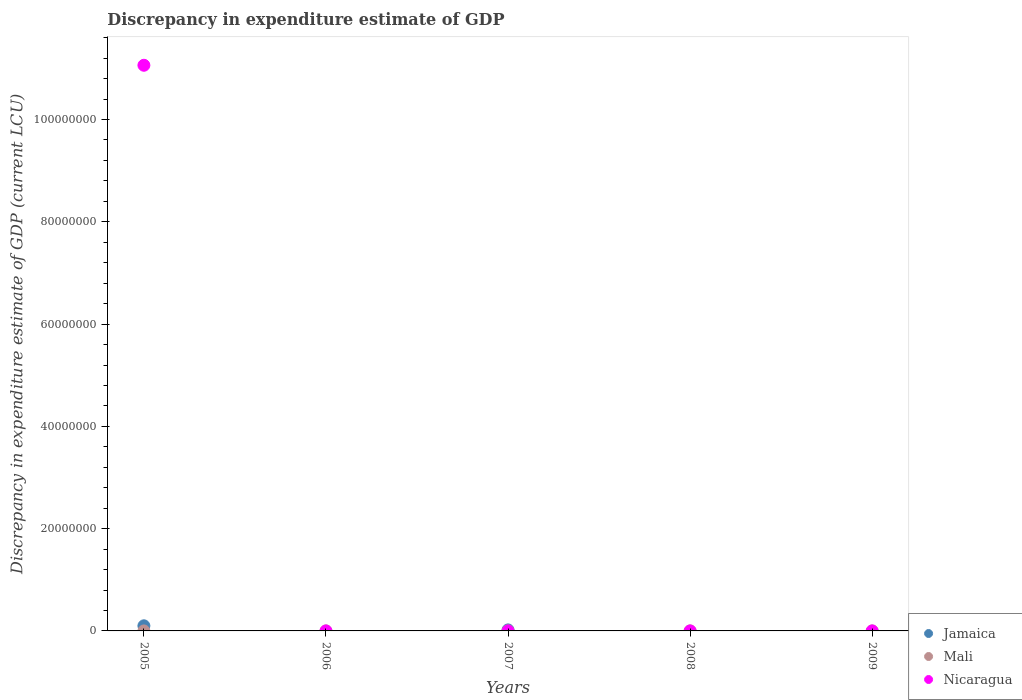How many different coloured dotlines are there?
Ensure brevity in your answer.  3. What is the discrepancy in expenditure estimate of GDP in Jamaica in 2005?
Provide a succinct answer. 1.00e+06. Across all years, what is the maximum discrepancy in expenditure estimate of GDP in Nicaragua?
Provide a succinct answer. 1.11e+08. What is the total discrepancy in expenditure estimate of GDP in Nicaragua in the graph?
Keep it short and to the point. 1.11e+08. What is the difference between the discrepancy in expenditure estimate of GDP in Mali in 2006 and that in 2008?
Provide a succinct answer. 0. What is the difference between the discrepancy in expenditure estimate of GDP in Nicaragua in 2006 and the discrepancy in expenditure estimate of GDP in Mali in 2007?
Provide a succinct answer. -0. What is the average discrepancy in expenditure estimate of GDP in Jamaica per year?
Keep it short and to the point. 2.40e+05. In the year 2007, what is the difference between the discrepancy in expenditure estimate of GDP in Jamaica and discrepancy in expenditure estimate of GDP in Mali?
Your response must be concise. 2.00e+05. In how many years, is the discrepancy in expenditure estimate of GDP in Jamaica greater than 108000000 LCU?
Provide a succinct answer. 0. What is the ratio of the discrepancy in expenditure estimate of GDP in Mali in 2005 to that in 2008?
Make the answer very short. 1.87. What is the difference between the highest and the lowest discrepancy in expenditure estimate of GDP in Mali?
Make the answer very short. 0. Is the sum of the discrepancy in expenditure estimate of GDP in Mali in 2006 and 2008 greater than the maximum discrepancy in expenditure estimate of GDP in Nicaragua across all years?
Offer a terse response. No. Does the discrepancy in expenditure estimate of GDP in Nicaragua monotonically increase over the years?
Make the answer very short. No. Is the discrepancy in expenditure estimate of GDP in Nicaragua strictly greater than the discrepancy in expenditure estimate of GDP in Jamaica over the years?
Your response must be concise. No. How many years are there in the graph?
Offer a terse response. 5. What is the difference between two consecutive major ticks on the Y-axis?
Provide a succinct answer. 2.00e+07. Does the graph contain any zero values?
Provide a succinct answer. Yes. Where does the legend appear in the graph?
Give a very brief answer. Bottom right. How many legend labels are there?
Ensure brevity in your answer.  3. What is the title of the graph?
Offer a very short reply. Discrepancy in expenditure estimate of GDP. Does "Netherlands" appear as one of the legend labels in the graph?
Provide a short and direct response. No. What is the label or title of the Y-axis?
Keep it short and to the point. Discrepancy in expenditure estimate of GDP (current LCU). What is the Discrepancy in expenditure estimate of GDP (current LCU) of Jamaica in 2005?
Provide a succinct answer. 1.00e+06. What is the Discrepancy in expenditure estimate of GDP (current LCU) in Mali in 2005?
Ensure brevity in your answer.  0. What is the Discrepancy in expenditure estimate of GDP (current LCU) in Nicaragua in 2005?
Offer a terse response. 1.11e+08. What is the Discrepancy in expenditure estimate of GDP (current LCU) of Mali in 2006?
Your response must be concise. 0. What is the Discrepancy in expenditure estimate of GDP (current LCU) in Nicaragua in 2006?
Ensure brevity in your answer.  0. What is the Discrepancy in expenditure estimate of GDP (current LCU) of Jamaica in 2007?
Give a very brief answer. 2.00e+05. What is the Discrepancy in expenditure estimate of GDP (current LCU) of Mali in 2007?
Ensure brevity in your answer.  0. What is the Discrepancy in expenditure estimate of GDP (current LCU) in Nicaragua in 2007?
Give a very brief answer. 32.83. What is the Discrepancy in expenditure estimate of GDP (current LCU) in Mali in 2008?
Offer a very short reply. 0. What is the Discrepancy in expenditure estimate of GDP (current LCU) in Nicaragua in 2008?
Make the answer very short. 0. What is the Discrepancy in expenditure estimate of GDP (current LCU) of Jamaica in 2009?
Make the answer very short. 0. What is the Discrepancy in expenditure estimate of GDP (current LCU) of Mali in 2009?
Provide a succinct answer. 0. What is the Discrepancy in expenditure estimate of GDP (current LCU) in Nicaragua in 2009?
Your answer should be very brief. 0. Across all years, what is the maximum Discrepancy in expenditure estimate of GDP (current LCU) in Jamaica?
Your answer should be very brief. 1.00e+06. Across all years, what is the maximum Discrepancy in expenditure estimate of GDP (current LCU) of Mali?
Give a very brief answer. 0. Across all years, what is the maximum Discrepancy in expenditure estimate of GDP (current LCU) of Nicaragua?
Your answer should be very brief. 1.11e+08. Across all years, what is the minimum Discrepancy in expenditure estimate of GDP (current LCU) of Jamaica?
Offer a very short reply. 0. Across all years, what is the minimum Discrepancy in expenditure estimate of GDP (current LCU) in Mali?
Your answer should be compact. 0. Across all years, what is the minimum Discrepancy in expenditure estimate of GDP (current LCU) of Nicaragua?
Keep it short and to the point. 0. What is the total Discrepancy in expenditure estimate of GDP (current LCU) of Jamaica in the graph?
Offer a very short reply. 1.20e+06. What is the total Discrepancy in expenditure estimate of GDP (current LCU) in Mali in the graph?
Provide a short and direct response. 0.01. What is the total Discrepancy in expenditure estimate of GDP (current LCU) in Nicaragua in the graph?
Provide a short and direct response. 1.11e+08. What is the difference between the Discrepancy in expenditure estimate of GDP (current LCU) in Mali in 2005 and that in 2006?
Your answer should be compact. 0. What is the difference between the Discrepancy in expenditure estimate of GDP (current LCU) of Jamaica in 2005 and that in 2007?
Your response must be concise. 8.00e+05. What is the difference between the Discrepancy in expenditure estimate of GDP (current LCU) in Mali in 2005 and that in 2007?
Your answer should be very brief. 0. What is the difference between the Discrepancy in expenditure estimate of GDP (current LCU) in Nicaragua in 2005 and that in 2007?
Keep it short and to the point. 1.11e+08. What is the difference between the Discrepancy in expenditure estimate of GDP (current LCU) of Mali in 2005 and that in 2008?
Provide a succinct answer. 0. What is the difference between the Discrepancy in expenditure estimate of GDP (current LCU) in Mali in 2006 and that in 2007?
Your answer should be compact. 0. What is the difference between the Discrepancy in expenditure estimate of GDP (current LCU) in Mali in 2006 and that in 2008?
Ensure brevity in your answer.  0. What is the difference between the Discrepancy in expenditure estimate of GDP (current LCU) of Mali in 2007 and that in 2008?
Your response must be concise. -0. What is the difference between the Discrepancy in expenditure estimate of GDP (current LCU) in Jamaica in 2005 and the Discrepancy in expenditure estimate of GDP (current LCU) in Mali in 2006?
Offer a terse response. 1.00e+06. What is the difference between the Discrepancy in expenditure estimate of GDP (current LCU) of Jamaica in 2005 and the Discrepancy in expenditure estimate of GDP (current LCU) of Mali in 2007?
Make the answer very short. 1.00e+06. What is the difference between the Discrepancy in expenditure estimate of GDP (current LCU) in Jamaica in 2005 and the Discrepancy in expenditure estimate of GDP (current LCU) in Nicaragua in 2007?
Provide a short and direct response. 1.00e+06. What is the difference between the Discrepancy in expenditure estimate of GDP (current LCU) of Mali in 2005 and the Discrepancy in expenditure estimate of GDP (current LCU) of Nicaragua in 2007?
Offer a terse response. -32.83. What is the difference between the Discrepancy in expenditure estimate of GDP (current LCU) in Jamaica in 2005 and the Discrepancy in expenditure estimate of GDP (current LCU) in Mali in 2008?
Provide a succinct answer. 1.00e+06. What is the difference between the Discrepancy in expenditure estimate of GDP (current LCU) of Mali in 2006 and the Discrepancy in expenditure estimate of GDP (current LCU) of Nicaragua in 2007?
Give a very brief answer. -32.83. What is the difference between the Discrepancy in expenditure estimate of GDP (current LCU) of Jamaica in 2007 and the Discrepancy in expenditure estimate of GDP (current LCU) of Mali in 2008?
Make the answer very short. 2.00e+05. What is the average Discrepancy in expenditure estimate of GDP (current LCU) in Mali per year?
Provide a short and direct response. 0. What is the average Discrepancy in expenditure estimate of GDP (current LCU) of Nicaragua per year?
Your response must be concise. 2.21e+07. In the year 2005, what is the difference between the Discrepancy in expenditure estimate of GDP (current LCU) of Jamaica and Discrepancy in expenditure estimate of GDP (current LCU) of Mali?
Your response must be concise. 1.00e+06. In the year 2005, what is the difference between the Discrepancy in expenditure estimate of GDP (current LCU) in Jamaica and Discrepancy in expenditure estimate of GDP (current LCU) in Nicaragua?
Your answer should be compact. -1.10e+08. In the year 2005, what is the difference between the Discrepancy in expenditure estimate of GDP (current LCU) in Mali and Discrepancy in expenditure estimate of GDP (current LCU) in Nicaragua?
Provide a succinct answer. -1.11e+08. In the year 2007, what is the difference between the Discrepancy in expenditure estimate of GDP (current LCU) of Jamaica and Discrepancy in expenditure estimate of GDP (current LCU) of Mali?
Provide a succinct answer. 2.00e+05. In the year 2007, what is the difference between the Discrepancy in expenditure estimate of GDP (current LCU) in Jamaica and Discrepancy in expenditure estimate of GDP (current LCU) in Nicaragua?
Offer a terse response. 2.00e+05. In the year 2007, what is the difference between the Discrepancy in expenditure estimate of GDP (current LCU) of Mali and Discrepancy in expenditure estimate of GDP (current LCU) of Nicaragua?
Keep it short and to the point. -32.83. What is the ratio of the Discrepancy in expenditure estimate of GDP (current LCU) in Mali in 2005 to that in 2006?
Make the answer very short. 1.36. What is the ratio of the Discrepancy in expenditure estimate of GDP (current LCU) in Mali in 2005 to that in 2007?
Provide a succinct answer. 2.01. What is the ratio of the Discrepancy in expenditure estimate of GDP (current LCU) in Nicaragua in 2005 to that in 2007?
Give a very brief answer. 3.37e+06. What is the ratio of the Discrepancy in expenditure estimate of GDP (current LCU) of Mali in 2005 to that in 2008?
Keep it short and to the point. 1.87. What is the ratio of the Discrepancy in expenditure estimate of GDP (current LCU) in Mali in 2006 to that in 2007?
Ensure brevity in your answer.  1.48. What is the ratio of the Discrepancy in expenditure estimate of GDP (current LCU) of Mali in 2006 to that in 2008?
Your response must be concise. 1.37. What is the ratio of the Discrepancy in expenditure estimate of GDP (current LCU) of Mali in 2007 to that in 2008?
Ensure brevity in your answer.  0.93. What is the difference between the highest and the second highest Discrepancy in expenditure estimate of GDP (current LCU) of Mali?
Your answer should be compact. 0. What is the difference between the highest and the lowest Discrepancy in expenditure estimate of GDP (current LCU) of Mali?
Keep it short and to the point. 0. What is the difference between the highest and the lowest Discrepancy in expenditure estimate of GDP (current LCU) of Nicaragua?
Offer a very short reply. 1.11e+08. 